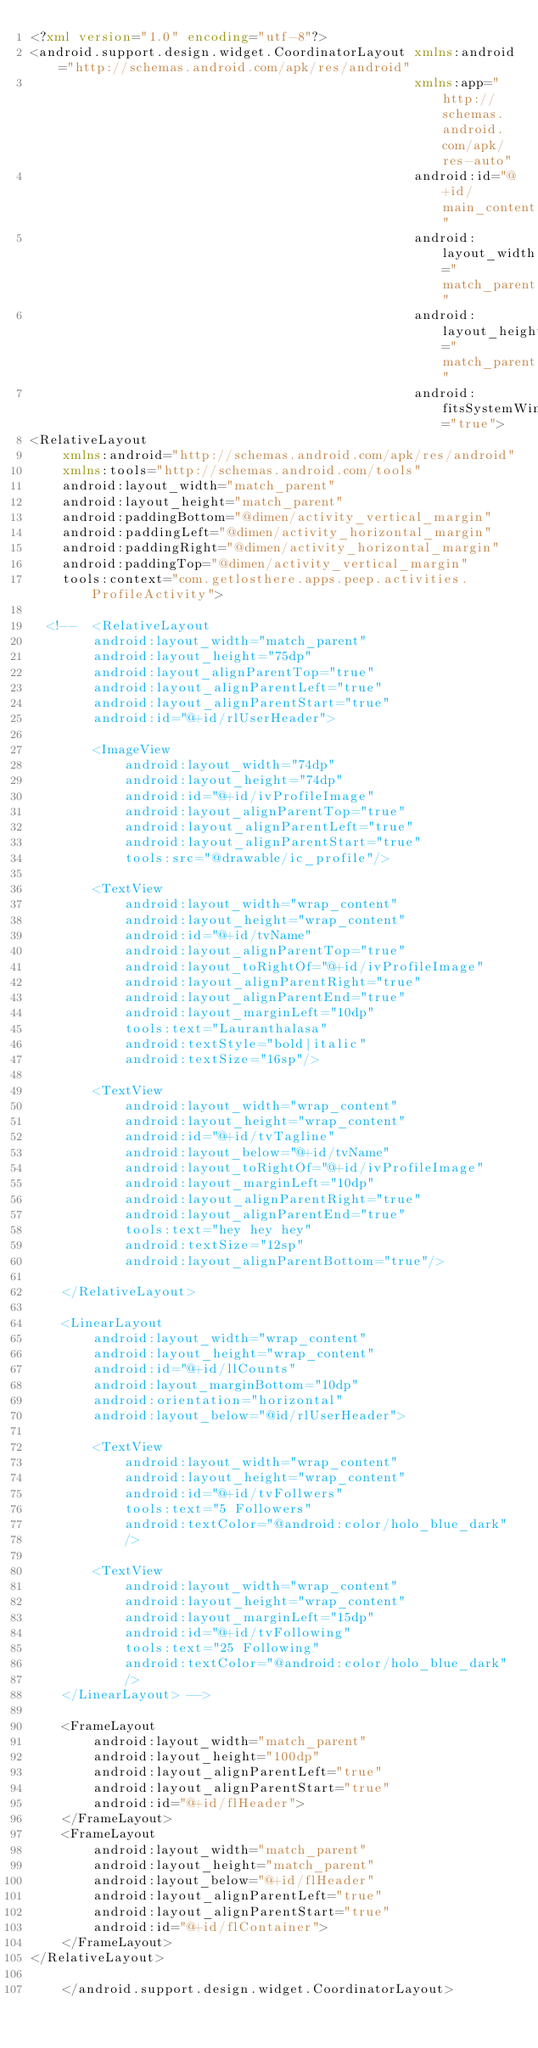Convert code to text. <code><loc_0><loc_0><loc_500><loc_500><_XML_><?xml version="1.0" encoding="utf-8"?>
<android.support.design.widget.CoordinatorLayout xmlns:android="http://schemas.android.com/apk/res/android"
                                                 xmlns:app="http://schemas.android.com/apk/res-auto"
                                                 android:id="@+id/main_content"
                                                 android:layout_width="match_parent"
                                                 android:layout_height="match_parent"
                                                 android:fitsSystemWindows="true">
<RelativeLayout
    xmlns:android="http://schemas.android.com/apk/res/android"
    xmlns:tools="http://schemas.android.com/tools"
    android:layout_width="match_parent"
    android:layout_height="match_parent"
    android:paddingBottom="@dimen/activity_vertical_margin"
    android:paddingLeft="@dimen/activity_horizontal_margin"
    android:paddingRight="@dimen/activity_horizontal_margin"
    android:paddingTop="@dimen/activity_vertical_margin"
    tools:context="com.getlosthere.apps.peep.activities.ProfileActivity">

  <!--  <RelativeLayout
        android:layout_width="match_parent"
        android:layout_height="75dp"
        android:layout_alignParentTop="true"
        android:layout_alignParentLeft="true"
        android:layout_alignParentStart="true"
        android:id="@+id/rlUserHeader">

        <ImageView
            android:layout_width="74dp"
            android:layout_height="74dp"
            android:id="@+id/ivProfileImage"
            android:layout_alignParentTop="true"
            android:layout_alignParentLeft="true"
            android:layout_alignParentStart="true"
            tools:src="@drawable/ic_profile"/>

        <TextView
            android:layout_width="wrap_content"
            android:layout_height="wrap_content"
            android:id="@+id/tvName"
            android:layout_alignParentTop="true"
            android:layout_toRightOf="@+id/ivProfileImage"
            android:layout_alignParentRight="true"
            android:layout_alignParentEnd="true"
            android:layout_marginLeft="10dp"
            tools:text="Lauranthalasa"
            android:textStyle="bold|italic"
            android:textSize="16sp"/>

        <TextView
            android:layout_width="wrap_content"
            android:layout_height="wrap_content"
            android:id="@+id/tvTagline"
            android:layout_below="@+id/tvName"
            android:layout_toRightOf="@+id/ivProfileImage"
            android:layout_marginLeft="10dp"
            android:layout_alignParentRight="true"
            android:layout_alignParentEnd="true"
            tools:text="hey hey hey"
            android:textSize="12sp"
            android:layout_alignParentBottom="true"/>

    </RelativeLayout>

    <LinearLayout
        android:layout_width="wrap_content"
        android:layout_height="wrap_content"
        android:id="@+id/llCounts"
        android:layout_marginBottom="10dp"
        android:orientation="horizontal"
        android:layout_below="@id/rlUserHeader">

        <TextView
            android:layout_width="wrap_content"
            android:layout_height="wrap_content"
            android:id="@+id/tvFollwers"
            tools:text="5 Followers"
            android:textColor="@android:color/holo_blue_dark"
            />

        <TextView
            android:layout_width="wrap_content"
            android:layout_height="wrap_content"
            android:layout_marginLeft="15dp"
            android:id="@+id/tvFollowing"
            tools:text="25 Following"
            android:textColor="@android:color/holo_blue_dark"
            />
    </LinearLayout> -->

    <FrameLayout
        android:layout_width="match_parent"
        android:layout_height="100dp"
        android:layout_alignParentLeft="true"
        android:layout_alignParentStart="true"
        android:id="@+id/flHeader">
    </FrameLayout>
    <FrameLayout
        android:layout_width="match_parent"
        android:layout_height="match_parent"
        android:layout_below="@+id/flHeader"
        android:layout_alignParentLeft="true"
        android:layout_alignParentStart="true"
        android:id="@+id/flContainer">
    </FrameLayout>
</RelativeLayout>

    </android.support.design.widget.CoordinatorLayout></code> 